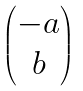<formula> <loc_0><loc_0><loc_500><loc_500>\begin{pmatrix} - a \\ b \end{pmatrix}</formula> 